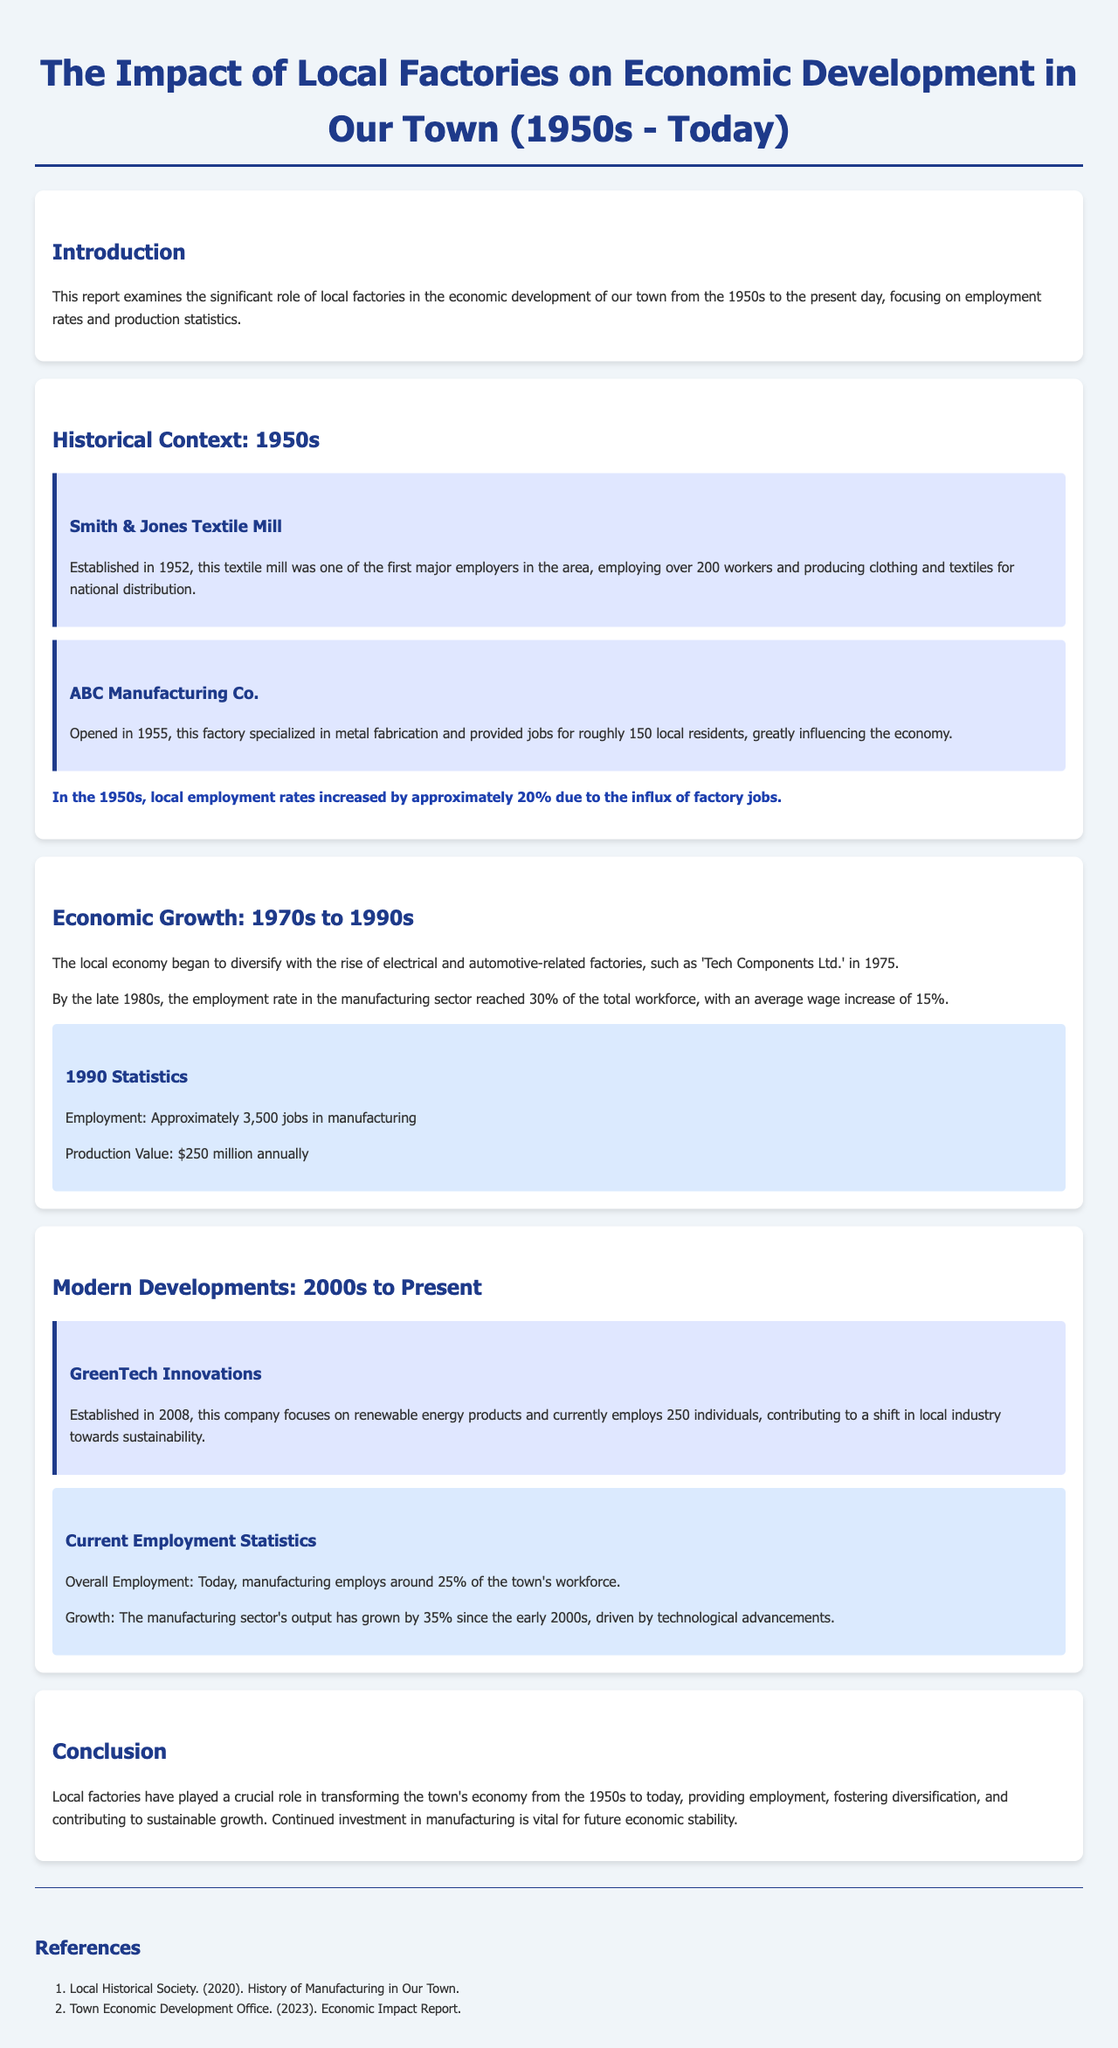what year was the Smith & Jones Textile Mill established? The report states that the Smith & Jones Textile Mill was established in 1952.
Answer: 1952 how many workers were employed by ABC Manufacturing Co.? According to the report, ABC Manufacturing Co. employed roughly 150 local residents.
Answer: 150 what percentage of the total workforce was employed in manufacturing by the late 1980s? The report mentions that by the late 1980s, the employment rate in the manufacturing sector reached 30% of the total workforce.
Answer: 30% what was the production value in 1990? The report indicates that the production value in 1990 was $250 million annually.
Answer: $250 million how many jobs did GreenTech Innovations provide? The report states that GreenTech Innovations currently employs 250 individuals.
Answer: 250 what was the overall employment percentage in manufacturing today? According to the report, today, manufacturing employs around 25% of the town's workforce.
Answer: 25% what is the growth percentage of the manufacturing sector's output since the early 2000s? The report indicates that the manufacturing sector's output has grown by 35% since the early 2000s.
Answer: 35% which company specialized in metal fabrication? The report mentions that ABC Manufacturing Co. specialized in metal fabrication.
Answer: ABC Manufacturing Co what time period does the report cover? The report covers the economic development from the 1950s to today.
Answer: 1950s to today 